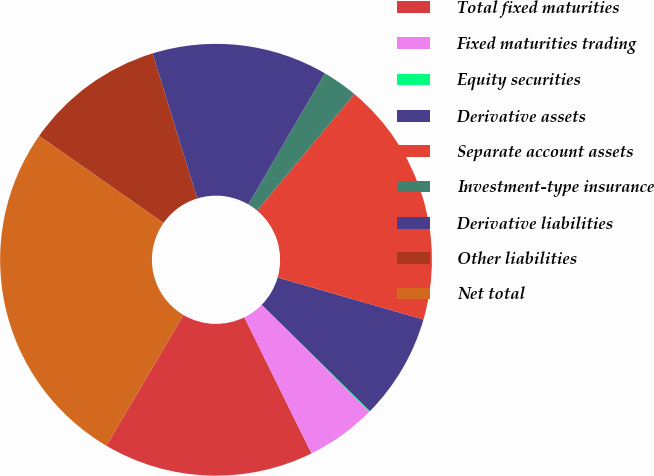Convert chart to OTSL. <chart><loc_0><loc_0><loc_500><loc_500><pie_chart><fcel>Total fixed maturities<fcel>Fixed maturities trading<fcel>Equity securities<fcel>Derivative assets<fcel>Separate account assets<fcel>Investment-type insurance<fcel>Derivative liabilities<fcel>Other liabilities<fcel>Net total<nl><fcel>15.77%<fcel>5.29%<fcel>0.05%<fcel>7.91%<fcel>18.39%<fcel>2.67%<fcel>13.15%<fcel>10.53%<fcel>26.24%<nl></chart> 